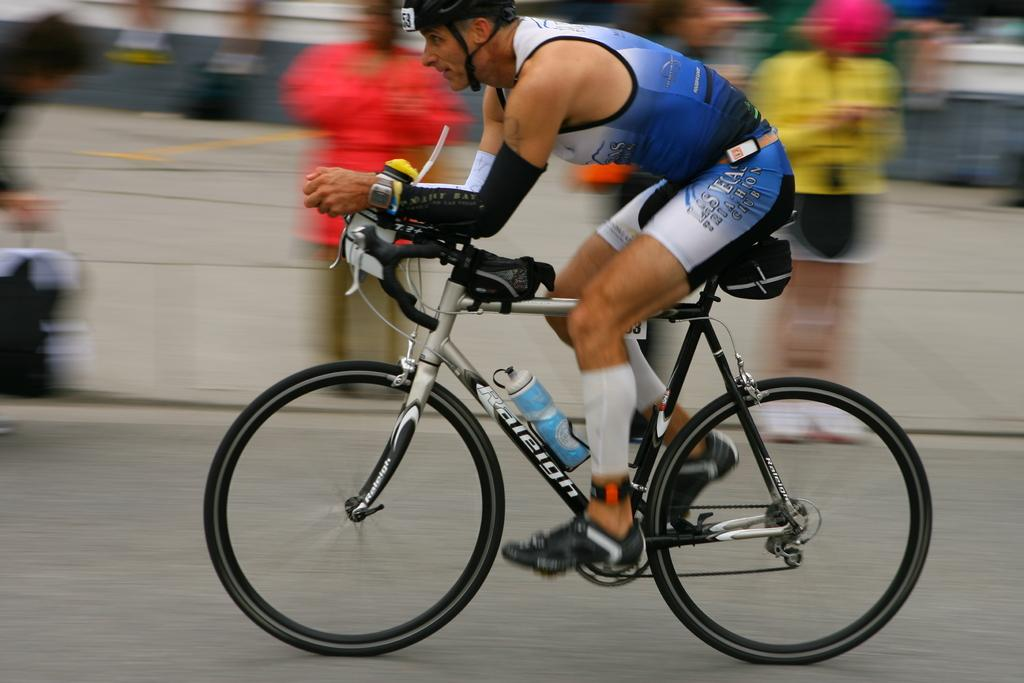What is the man in the image doing? The man is riding a bicycle in the image. What protective gear is the man wearing while riding the bicycle? The man is wearing a helmet in the image. What type of footwear is the man wearing? The man is wearing shoes in the image. What object can be seen in the image besides the man and his bicycle? There is a bottle in the image. What are the people in the background of the image doing? The people are standing and watching the man ride the bicycle in the image. What type of doctor is treating the man in the image? There is no doctor present in the image; the man is riding a bicycle. What is the chance of encountering wild animals while the man is riding the bicycle in the image? The image does not provide information about the location or the presence of wild animals, so it is impossible to determine the chance of encountering them. 